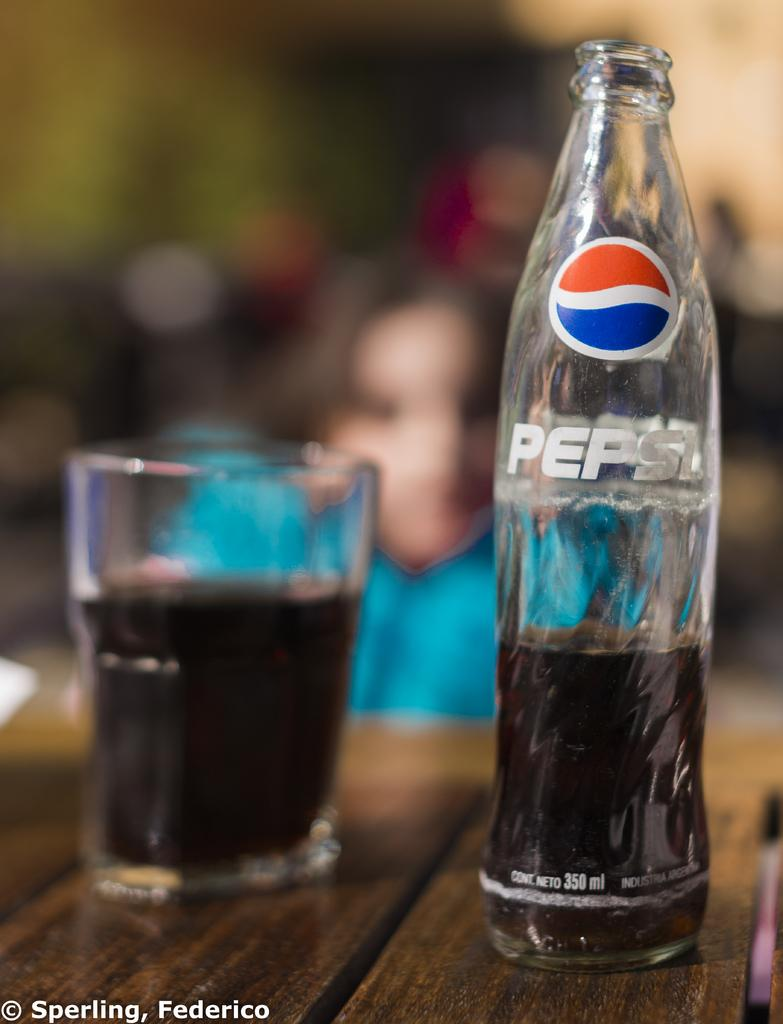<image>
Create a compact narrative representing the image presented. A glass bottle of Pepsi sits next to a glass of the drink. 